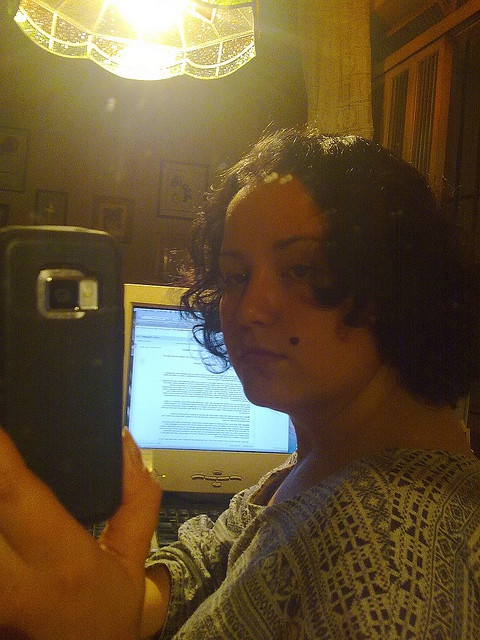Describe the objects in this image and their specific colors. I can see people in gray, maroon, black, olive, and brown tones, cell phone in gray, black, and olive tones, tv in gray, lightblue, and olive tones, and keyboard in gray, black, and darkgreen tones in this image. 